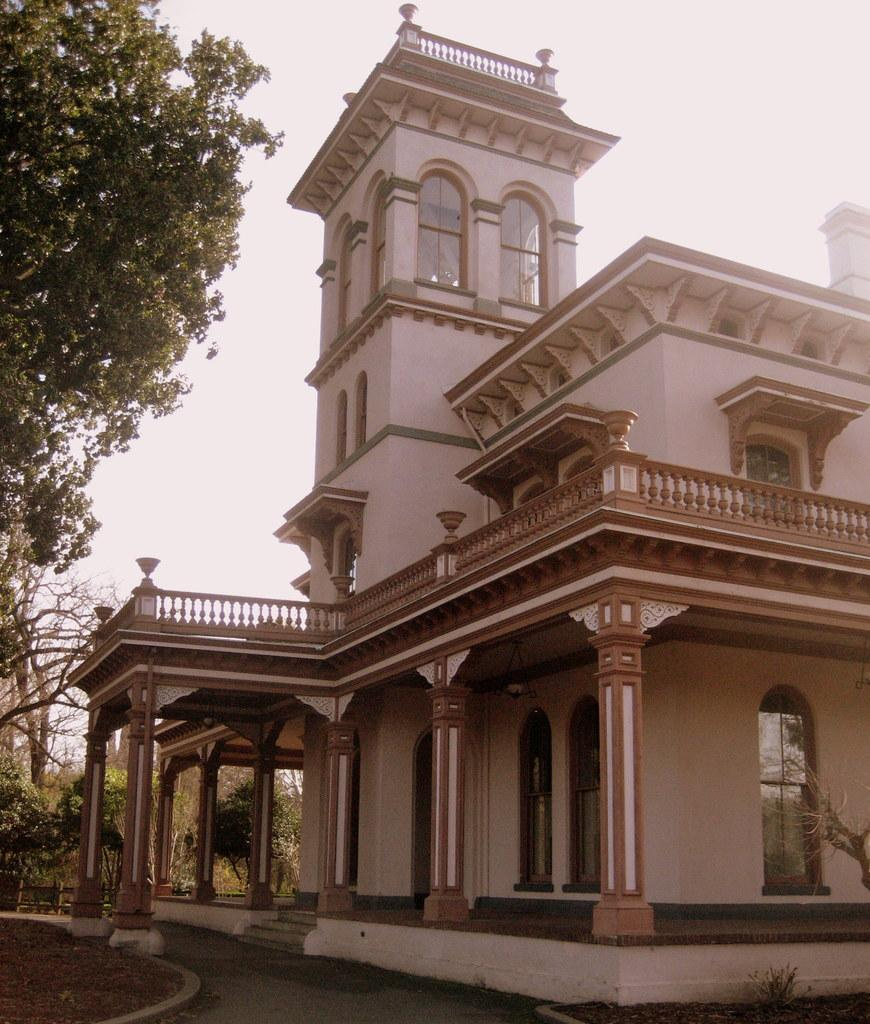What type of structures are present in the image? There are buildings in the image. What colors are the buildings? The buildings are in white and brown colors. What other natural elements can be seen in the image? There are trees in the image. What color are the trees? The trees are in green color. What is visible in the background of the image? The sky is visible in the background of the image. What color is the sky? The sky is in white color. Can you see a fight between a frog and a spark in the image? No, there is no fight between a frog and a spark in the image. 